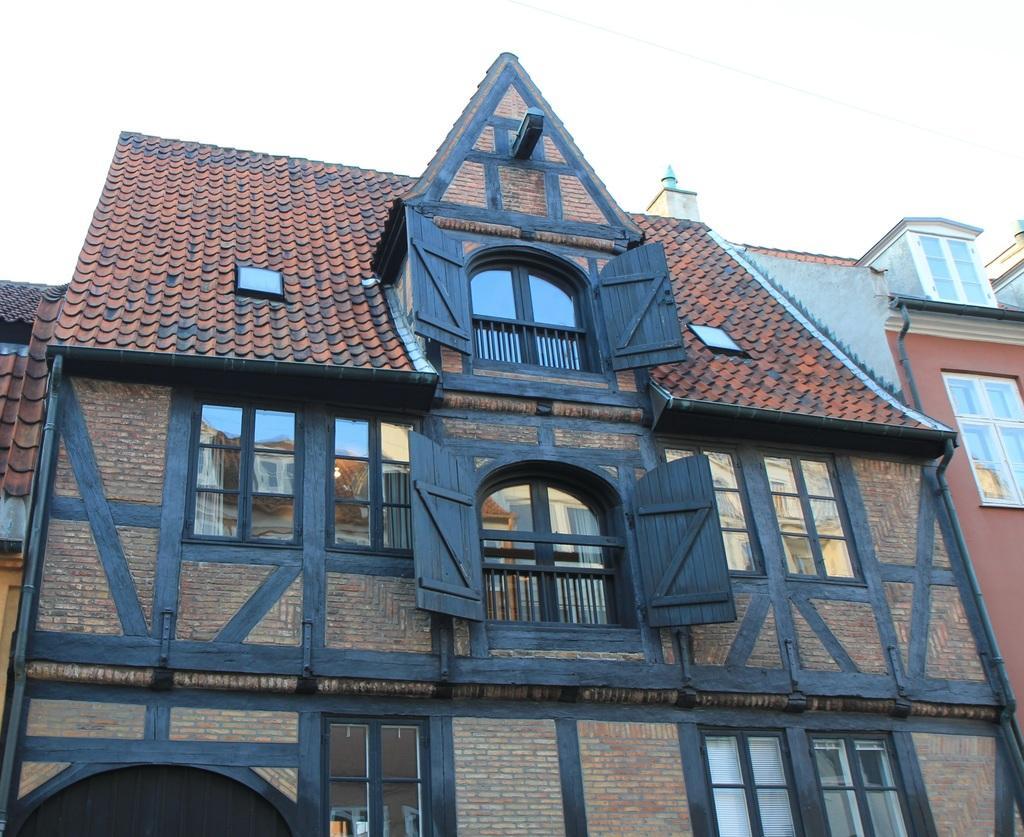Can you describe this image briefly? In this image there are buildings with windows and iron grills , and in the background there is sky. 